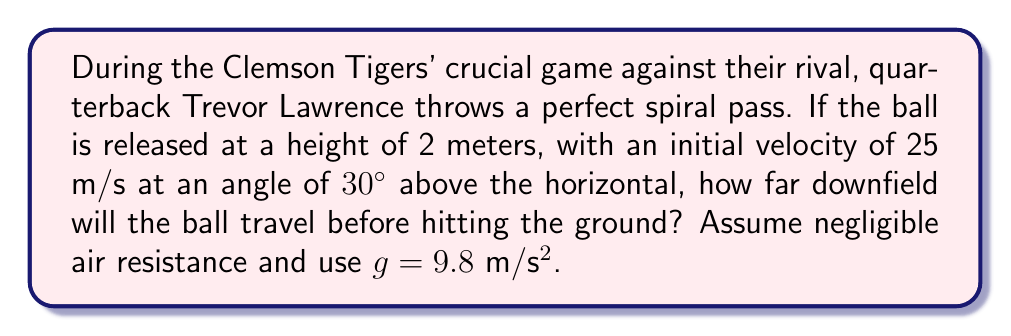Can you solve this math problem? Let's approach this step-by-step using the equations of projectile motion:

1) First, we need to decompose the initial velocity into its horizontal and vertical components:
   $v_x = v \cos \theta = 25 \cos 30° = 21.65$ m/s
   $v_y = v \sin \theta = 25 \sin 30° = 12.5$ m/s

2) The time of flight can be calculated using the vertical motion equation:
   $y = y_0 + v_y t - \frac{1}{2}gt^2$
   
   At the point of landing, y = 0 and y₀ = 2 m. Substituting:
   $0 = 2 + 12.5t - 4.9t^2$

3) This quadratic equation can be solved for t:
   $4.9t^2 - 12.5t - 2 = 0$
   
   Using the quadratic formula: $t = \frac{12.5 \pm \sqrt{12.5^2 + 4(4.9)(2)}}{2(4.9)}$
   
   $t = 2.86$ seconds (we take the positive root as time can't be negative)

4) Now that we know the time of flight, we can calculate the horizontal distance traveled:
   $x = v_x t = 21.65 \times 2.86 = 61.92$ meters

Therefore, the ball will travel approximately 61.92 meters downfield before hitting the ground.
Answer: 61.92 meters 